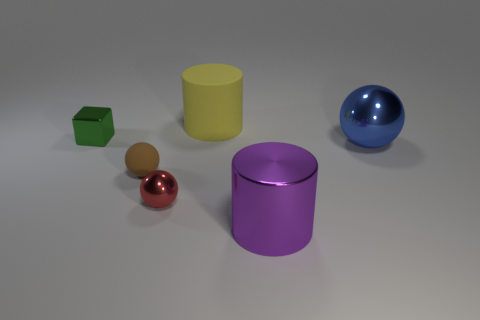What is the size of the purple metallic thing that is the same shape as the large yellow rubber object?
Provide a short and direct response. Large. Is there any other thing that has the same size as the rubber cylinder?
Offer a very short reply. Yes. Do the small green object and the yellow matte object have the same shape?
Offer a terse response. No. Are there fewer large rubber objects that are to the right of the big yellow rubber thing than small red spheres that are to the left of the brown rubber ball?
Your response must be concise. No. How many small shiny things are in front of the green metal block?
Your response must be concise. 1. There is a large metallic thing in front of the matte ball; does it have the same shape as the tiny metal thing that is left of the red ball?
Ensure brevity in your answer.  No. How many other things are the same color as the large rubber object?
Your answer should be compact. 0. There is a tiny thing that is behind the shiny sphere on the right side of the tiny shiny thing in front of the blue shiny thing; what is it made of?
Make the answer very short. Metal. What material is the big cylinder in front of the sphere that is on the right side of the big purple metal cylinder?
Ensure brevity in your answer.  Metal. Is the number of green metal things that are in front of the large metal ball less than the number of green objects?
Offer a terse response. Yes. 